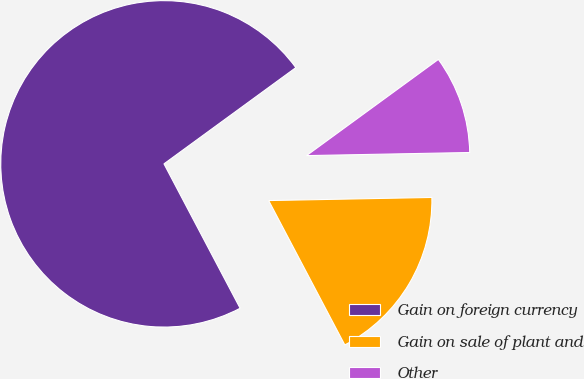Convert chart to OTSL. <chart><loc_0><loc_0><loc_500><loc_500><pie_chart><fcel>Gain on foreign currency<fcel>Gain on sale of plant and<fcel>Other<nl><fcel>72.69%<fcel>17.58%<fcel>9.73%<nl></chart> 